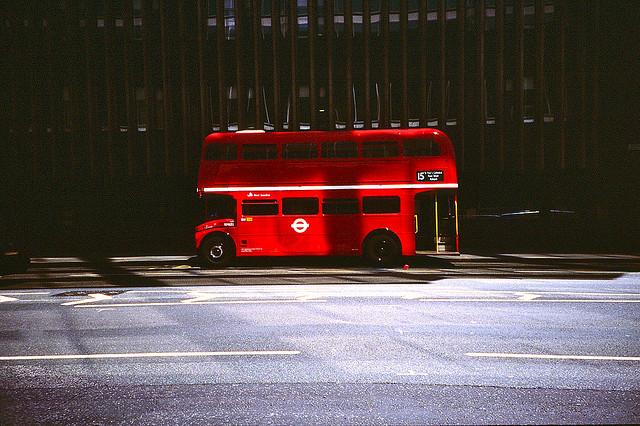How fast is the bus going?
Concise answer only. Stopped. What color is this bus?
Be succinct. Red. Is this a double decker bus?
Give a very brief answer. Yes. 